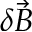<formula> <loc_0><loc_0><loc_500><loc_500>\delta \vec { B }</formula> 